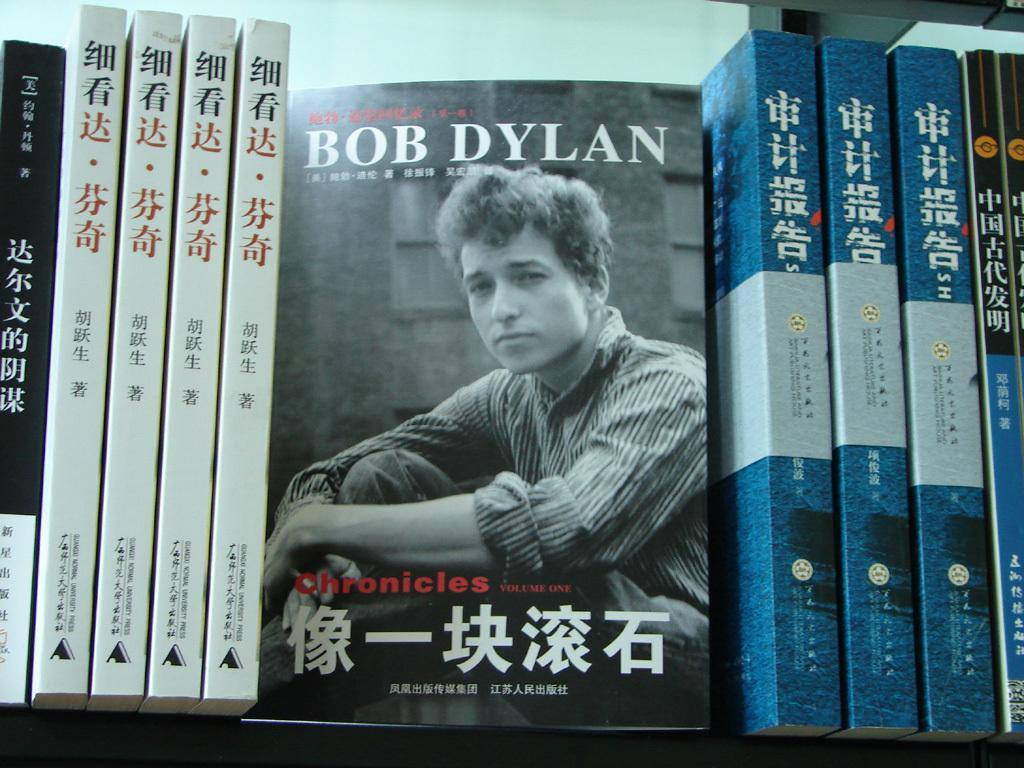<image>
Provide a brief description of the given image. A book about Bob Dylan is front facing on a shelf with other books. 